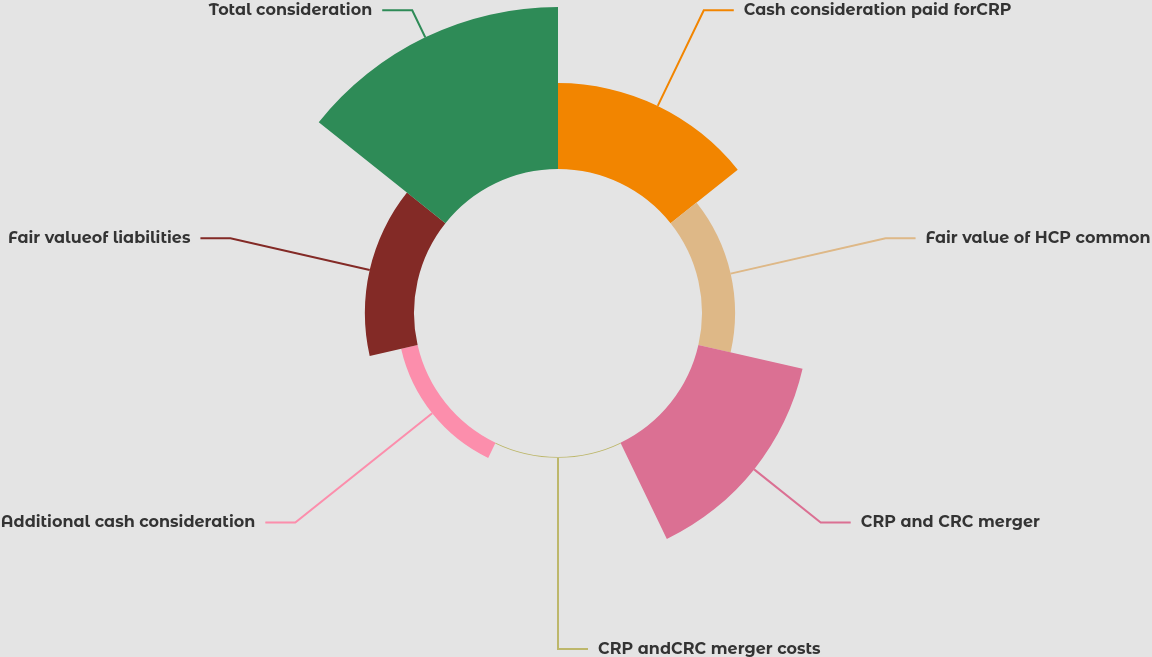Convert chart to OTSL. <chart><loc_0><loc_0><loc_500><loc_500><pie_chart><fcel>Cash consideration paid forCRP<fcel>Fair value of HCP common<fcel>CRP and CRC merger<fcel>CRP andCRC merger costs<fcel>Additional cash consideration<fcel>Fair valueof liabilities<fcel>Total consideration<nl><fcel>18.89%<fcel>7.27%<fcel>23.5%<fcel>0.18%<fcel>3.72%<fcel>10.81%<fcel>35.63%<nl></chart> 